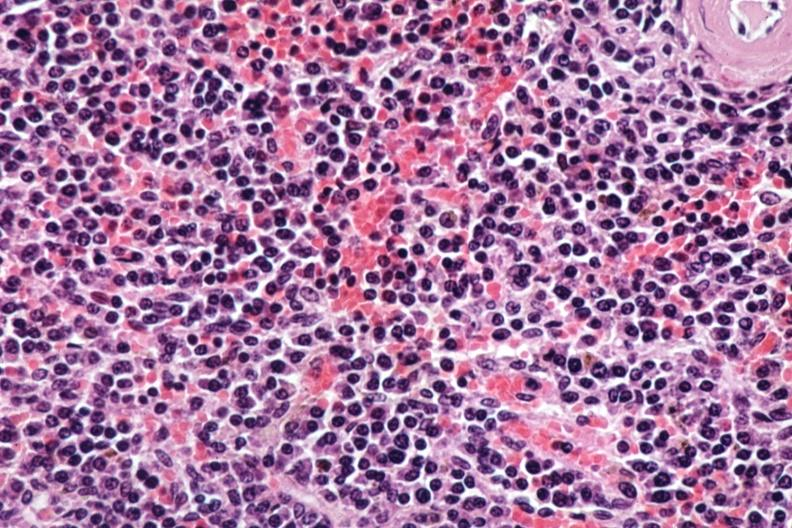does this image show sheets of atypical plasma cells?
Answer the question using a single word or phrase. Yes 